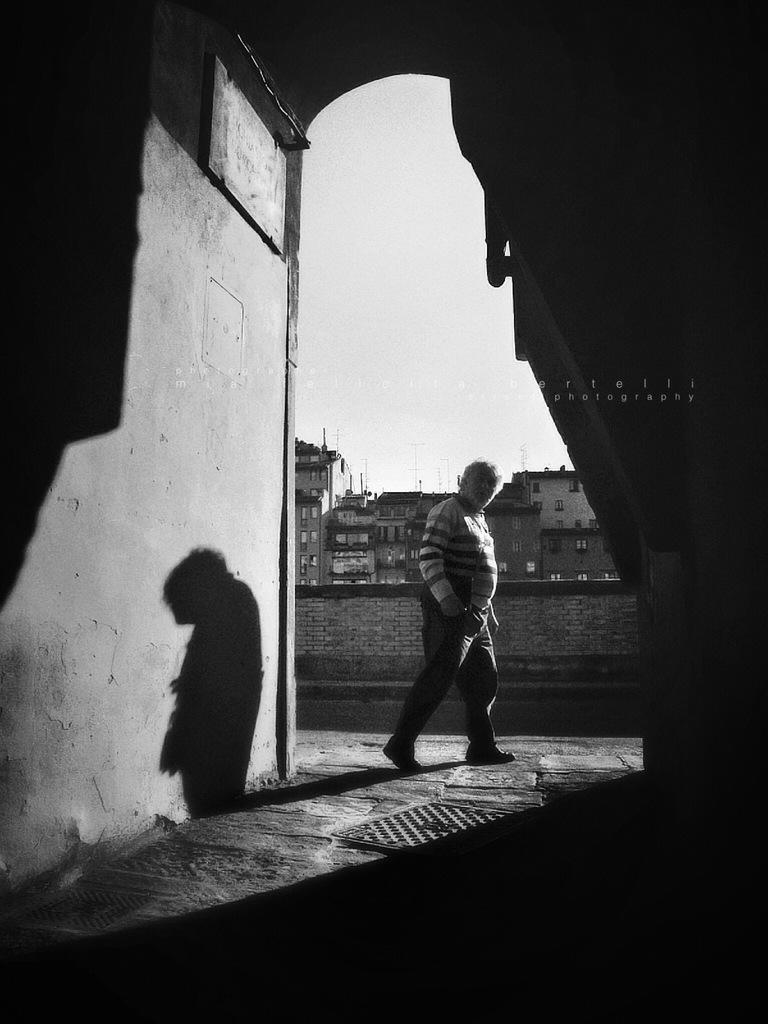Who is present in the image? There is a man in the image. What is the man doing in the image? The man is walking on the ground in the image. What can be seen in the background of the image? There are buildings and the sky visible in the background of the image. What is the color scheme of the image? The image is black and white in color. What class of spaceship is the man piloting in the image? There is no spaceship present in the image, and therefore no class of spaceship can be determined. 